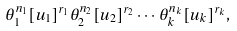<formula> <loc_0><loc_0><loc_500><loc_500>\theta _ { 1 } ^ { n _ { 1 } } [ u _ { 1 } ] ^ { r _ { 1 } } \theta _ { 2 } ^ { n _ { 2 } } [ u _ { 2 } ] ^ { r _ { 2 } } \cdots \theta _ { k } ^ { n _ { k } } [ u _ { k } ] ^ { r _ { k } } ,</formula> 